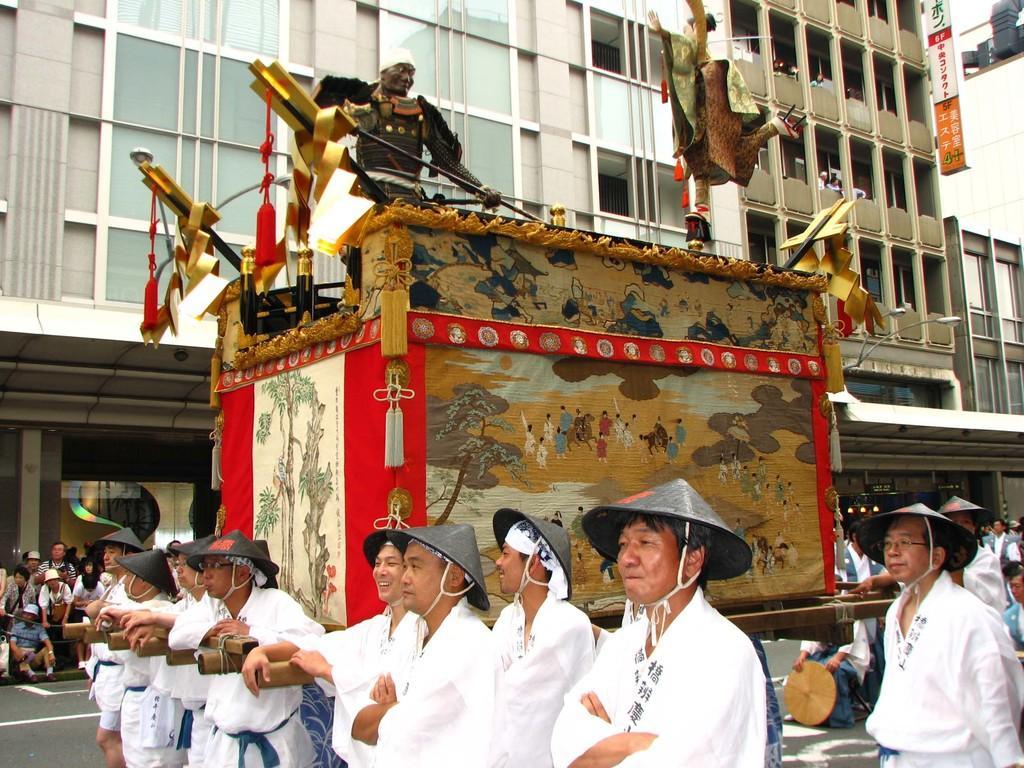Can you describe this image briefly? In this picture we can see some people dragging a trolley, there are some people standing here, these people wore caps, in the background there is a building, we can see a hoarding here, we can see glass here. 